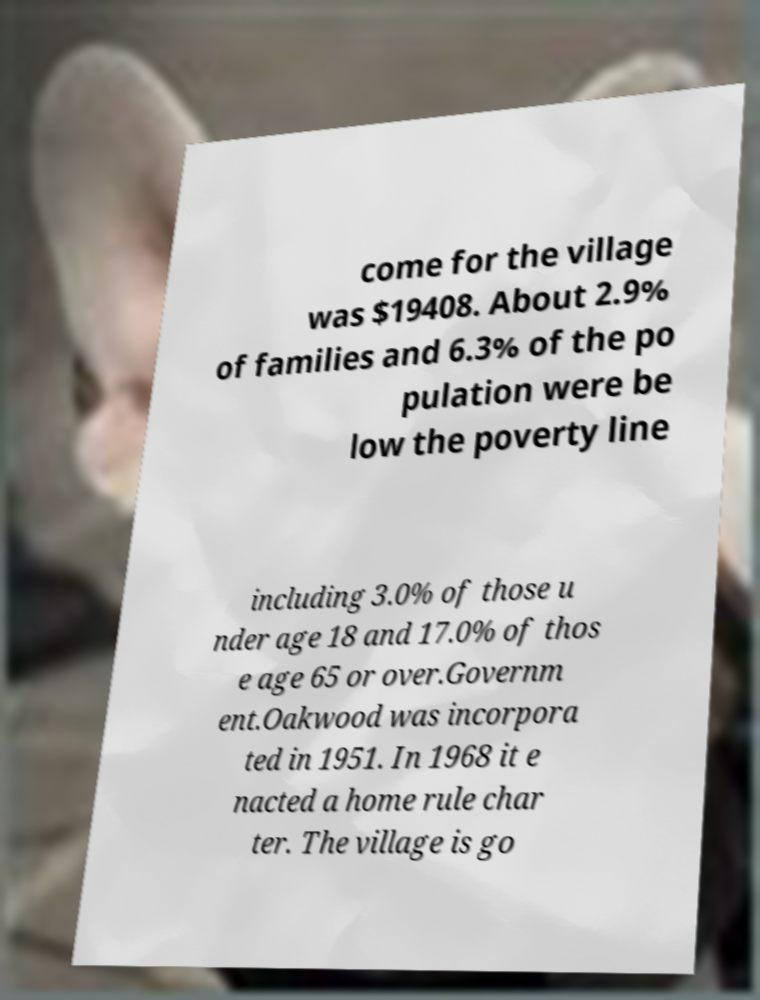Can you read and provide the text displayed in the image?This photo seems to have some interesting text. Can you extract and type it out for me? come for the village was $19408. About 2.9% of families and 6.3% of the po pulation were be low the poverty line including 3.0% of those u nder age 18 and 17.0% of thos e age 65 or over.Governm ent.Oakwood was incorpora ted in 1951. In 1968 it e nacted a home rule char ter. The village is go 